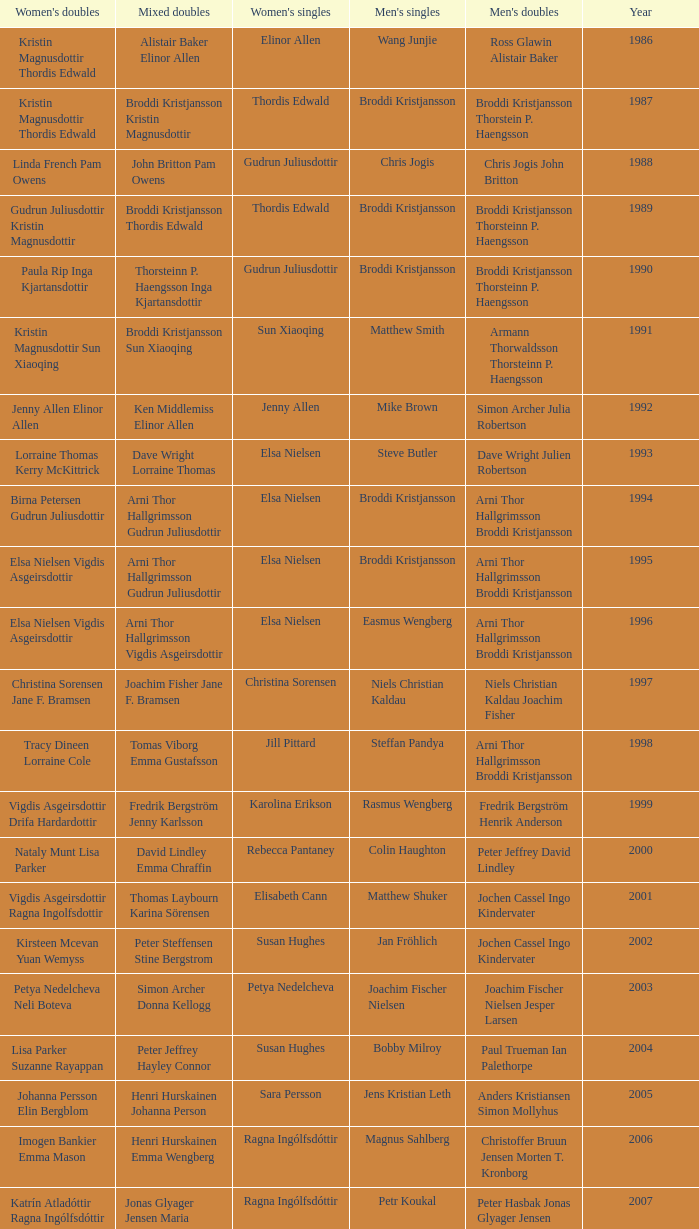In what mixed doubles did Niels Christian Kaldau play in men's singles? Joachim Fisher Jane F. Bramsen. Help me parse the entirety of this table. {'header': ["Women's doubles", 'Mixed doubles', "Women's singles", "Men's singles", "Men's doubles", 'Year'], 'rows': [['Kristin Magnusdottir Thordis Edwald', 'Alistair Baker Elinor Allen', 'Elinor Allen', 'Wang Junjie', 'Ross Glawin Alistair Baker', '1986'], ['Kristin Magnusdottir Thordis Edwald', 'Broddi Kristjansson Kristin Magnusdottir', 'Thordis Edwald', 'Broddi Kristjansson', 'Broddi Kristjansson Thorstein P. Haengsson', '1987'], ['Linda French Pam Owens', 'John Britton Pam Owens', 'Gudrun Juliusdottir', 'Chris Jogis', 'Chris Jogis John Britton', '1988'], ['Gudrun Juliusdottir Kristin Magnusdottir', 'Broddi Kristjansson Thordis Edwald', 'Thordis Edwald', 'Broddi Kristjansson', 'Broddi Kristjansson Thorsteinn P. Haengsson', '1989'], ['Paula Rip Inga Kjartansdottir', 'Thorsteinn P. Haengsson Inga Kjartansdottir', 'Gudrun Juliusdottir', 'Broddi Kristjansson', 'Broddi Kristjansson Thorsteinn P. Haengsson', '1990'], ['Kristin Magnusdottir Sun Xiaoqing', 'Broddi Kristjansson Sun Xiaoqing', 'Sun Xiaoqing', 'Matthew Smith', 'Armann Thorwaldsson Thorsteinn P. Haengsson', '1991'], ['Jenny Allen Elinor Allen', 'Ken Middlemiss Elinor Allen', 'Jenny Allen', 'Mike Brown', 'Simon Archer Julia Robertson', '1992'], ['Lorraine Thomas Kerry McKittrick', 'Dave Wright Lorraine Thomas', 'Elsa Nielsen', 'Steve Butler', 'Dave Wright Julien Robertson', '1993'], ['Birna Petersen Gudrun Juliusdottir', 'Arni Thor Hallgrimsson Gudrun Juliusdottir', 'Elsa Nielsen', 'Broddi Kristjansson', 'Arni Thor Hallgrimsson Broddi Kristjansson', '1994'], ['Elsa Nielsen Vigdis Asgeirsdottir', 'Arni Thor Hallgrimsson Gudrun Juliusdottir', 'Elsa Nielsen', 'Broddi Kristjansson', 'Arni Thor Hallgrimsson Broddi Kristjansson', '1995'], ['Elsa Nielsen Vigdis Asgeirsdottir', 'Arni Thor Hallgrimsson Vigdis Asgeirsdottir', 'Elsa Nielsen', 'Easmus Wengberg', 'Arni Thor Hallgrimsson Broddi Kristjansson', '1996'], ['Christina Sorensen Jane F. Bramsen', 'Joachim Fisher Jane F. Bramsen', 'Christina Sorensen', 'Niels Christian Kaldau', 'Niels Christian Kaldau Joachim Fisher', '1997'], ['Tracy Dineen Lorraine Cole', 'Tomas Viborg Emma Gustafsson', 'Jill Pittard', 'Steffan Pandya', 'Arni Thor Hallgrimsson Broddi Kristjansson', '1998'], ['Vigdis Asgeirsdottir Drifa Hardardottir', 'Fredrik Bergström Jenny Karlsson', 'Karolina Erikson', 'Rasmus Wengberg', 'Fredrik Bergström Henrik Anderson', '1999'], ['Nataly Munt Lisa Parker', 'David Lindley Emma Chraffin', 'Rebecca Pantaney', 'Colin Haughton', 'Peter Jeffrey David Lindley', '2000'], ['Vigdis Asgeirsdottir Ragna Ingolfsdottir', 'Thomas Laybourn Karina Sörensen', 'Elisabeth Cann', 'Matthew Shuker', 'Jochen Cassel Ingo Kindervater', '2001'], ['Kirsteen Mcevan Yuan Wemyss', 'Peter Steffensen Stine Bergstrom', 'Susan Hughes', 'Jan Fröhlich', 'Jochen Cassel Ingo Kindervater', '2002'], ['Petya Nedelcheva Neli Boteva', 'Simon Archer Donna Kellogg', 'Petya Nedelcheva', 'Joachim Fischer Nielsen', 'Joachim Fischer Nielsen Jesper Larsen', '2003'], ['Lisa Parker Suzanne Rayappan', 'Peter Jeffrey Hayley Connor', 'Susan Hughes', 'Bobby Milroy', 'Paul Trueman Ian Palethorpe', '2004'], ['Johanna Persson Elin Bergblom', 'Henri Hurskainen Johanna Person', 'Sara Persson', 'Jens Kristian Leth', 'Anders Kristiansen Simon Mollyhus', '2005'], ['Imogen Bankier Emma Mason', 'Henri Hurskainen Emma Wengberg', 'Ragna Ingólfsdóttir', 'Magnus Sahlberg', 'Christoffer Bruun Jensen Morten T. Kronborg', '2006'], ['Katrín Atladóttir Ragna Ingólfsdóttir', 'Jonas Glyager Jensen Maria Kaaberböl Thorberg', 'Ragna Ingólfsdóttir', 'Petr Koukal', 'Peter Hasbak Jonas Glyager Jensen', '2007'], ['No competition', 'No competition', 'No competition', 'No competition', 'No competition', '2008'], ['Ragna Ingólfsdóttir Snjólaug Jóhannsdóttir', 'Theis Christiansen Joan Christiansen', 'Ragna Ingólfsdóttir', 'Christian Lind Thomsen', 'Anders Skaarup Rasmussen René Lindskow', '2009'], ['Katrín Atladóttir Ragna Ingólfsdóttir', 'Frederik Colberg Mette Poulsen', 'Ragna Ingólfsdóttir', 'Kim Bruun', 'Emil Holst Mikkel Mikkelsen', '2010'], ['Tinna Helgadóttir Snjólaug Jóhannsdóttir', 'Thomas Dew-Hattens Louise Hansen', 'Ragna Ingólfsdóttir', 'Mathias Borg', 'Thomas Dew-Hattens Mathias Kany', '2011'], ['Lee So-hee Shin Seung-chan', 'Chou Tien-chen Chiang Mei-hui', 'Chiang Mei-hui', 'Chou Tien-chen', 'Joe Morgan Nic Strange', '2012']]} 